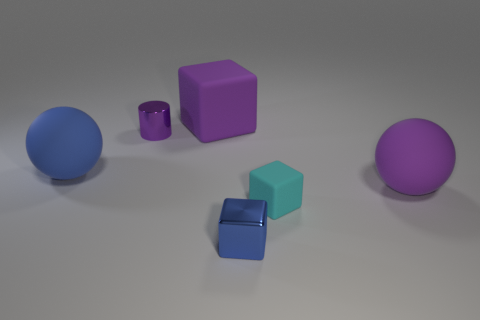Subtract all brown cylinders. Subtract all yellow cubes. How many cylinders are left? 1 Add 1 tiny metallic cubes. How many objects exist? 7 Subtract all spheres. How many objects are left? 4 Add 5 metal cubes. How many metal cubes exist? 6 Subtract 0 green cylinders. How many objects are left? 6 Subtract all big purple rubber balls. Subtract all small things. How many objects are left? 2 Add 5 tiny blue shiny things. How many tiny blue shiny things are left? 6 